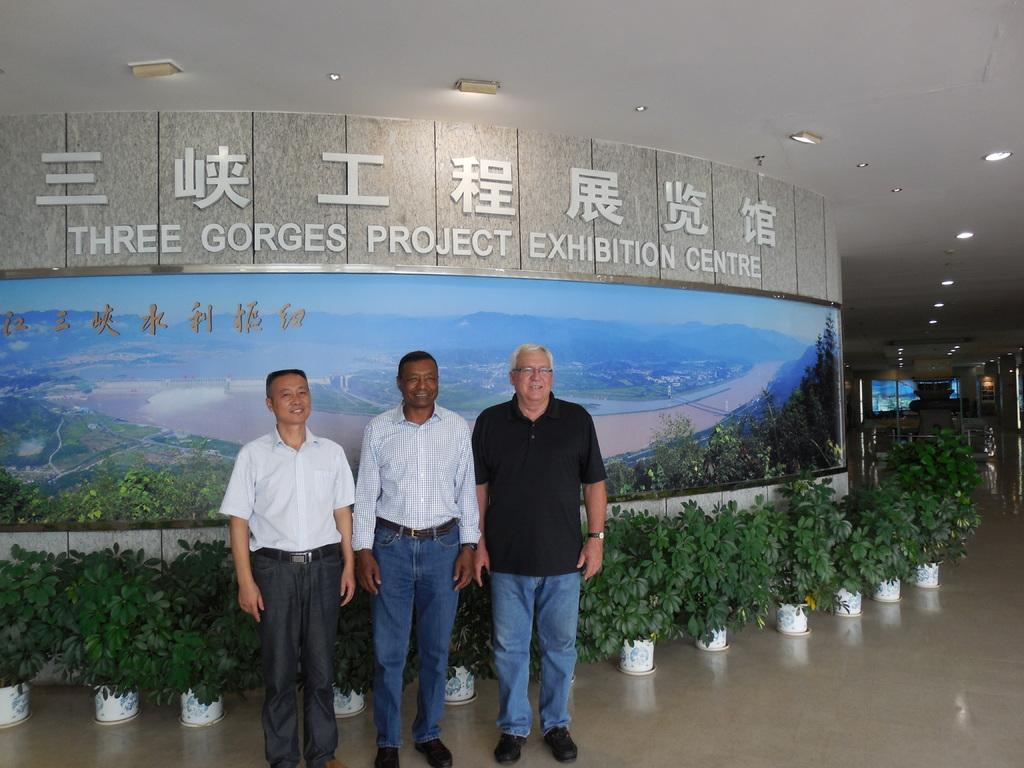How many men are in the image? There are three men standing in the image. What is the surface the men are standing on? The men are standing on the floor. What type of vegetation can be seen in the image? There are potted plants visible in the image. What is hanging from the ceiling in the image? There is a banner in the image. What is the background of the image made of? There is a wall in the image. What is visible at the top of the image? The roof is visible at the top of the image, and lights are present there. How many children are playing with the potted plants in the image? There are no children present in the image, and the potted plants are not being played with. 